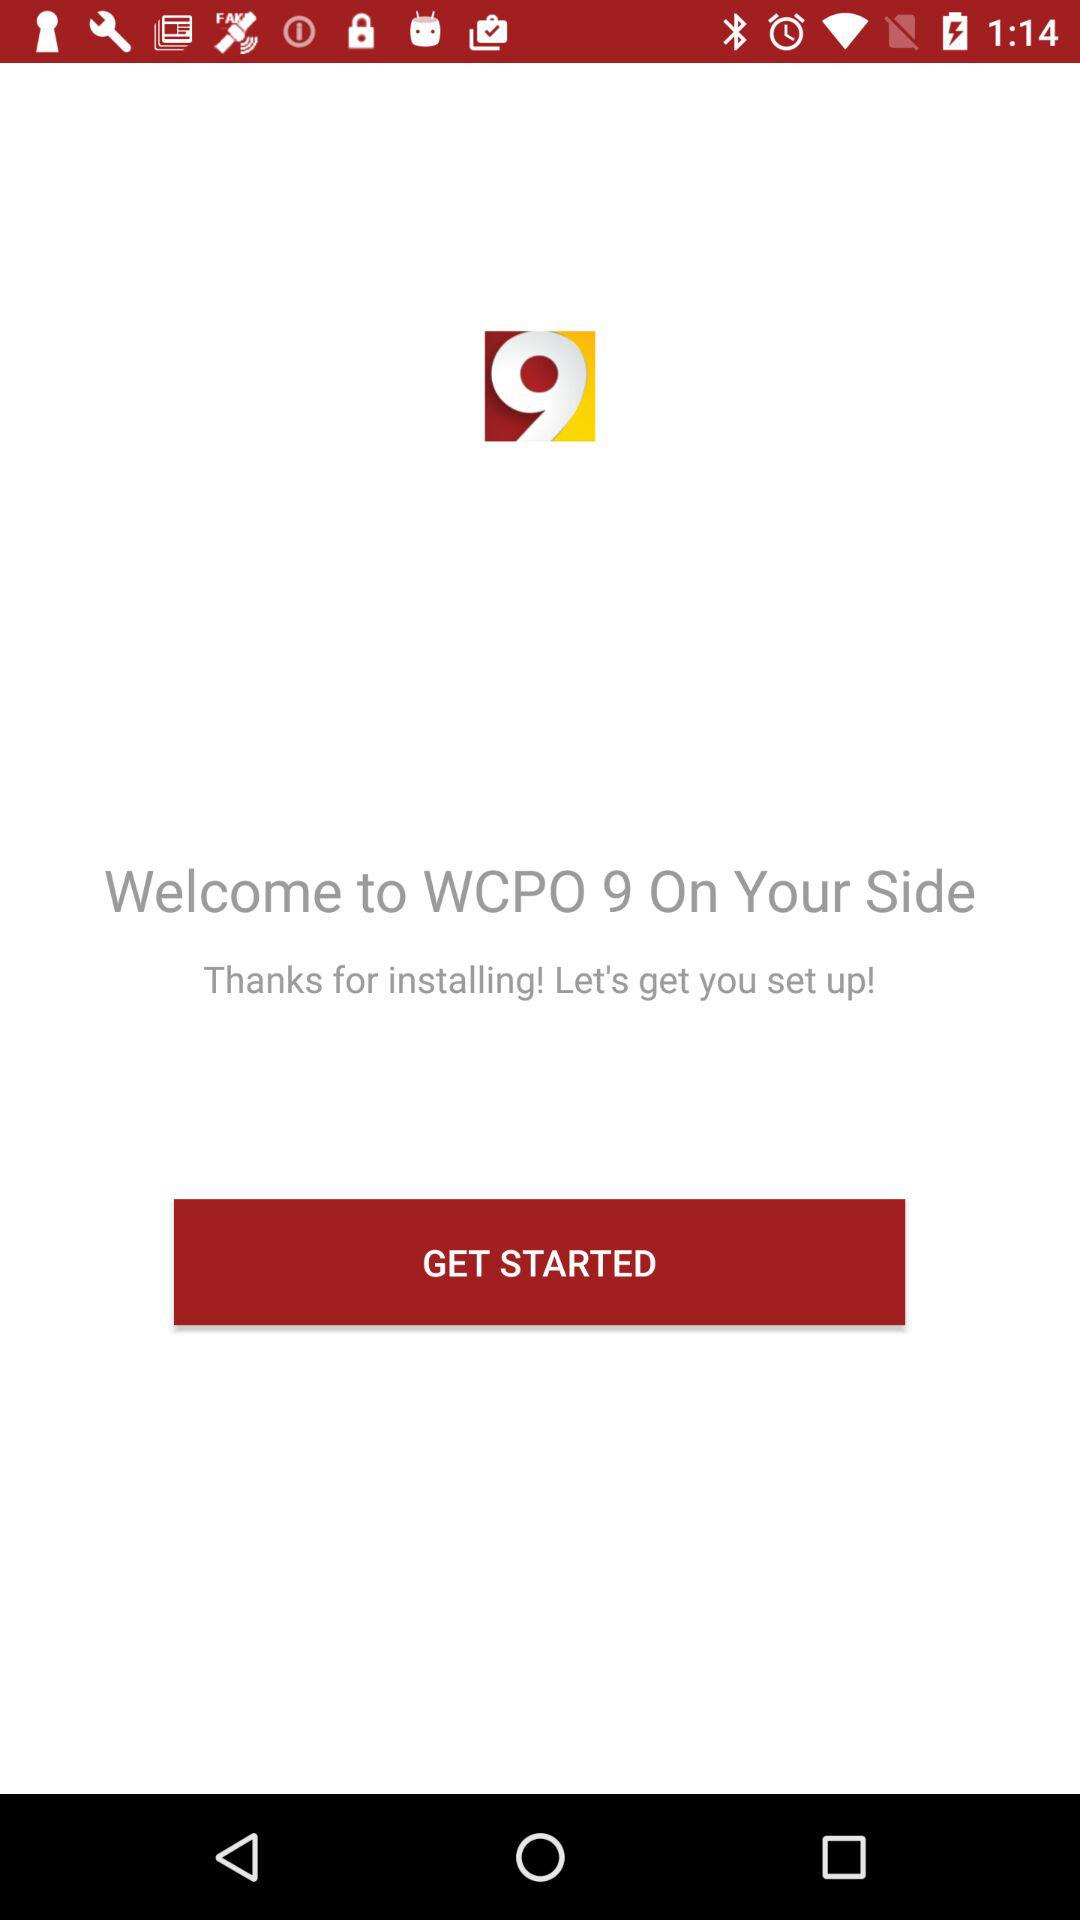What is the application name? The application name is "WCPO 9". 